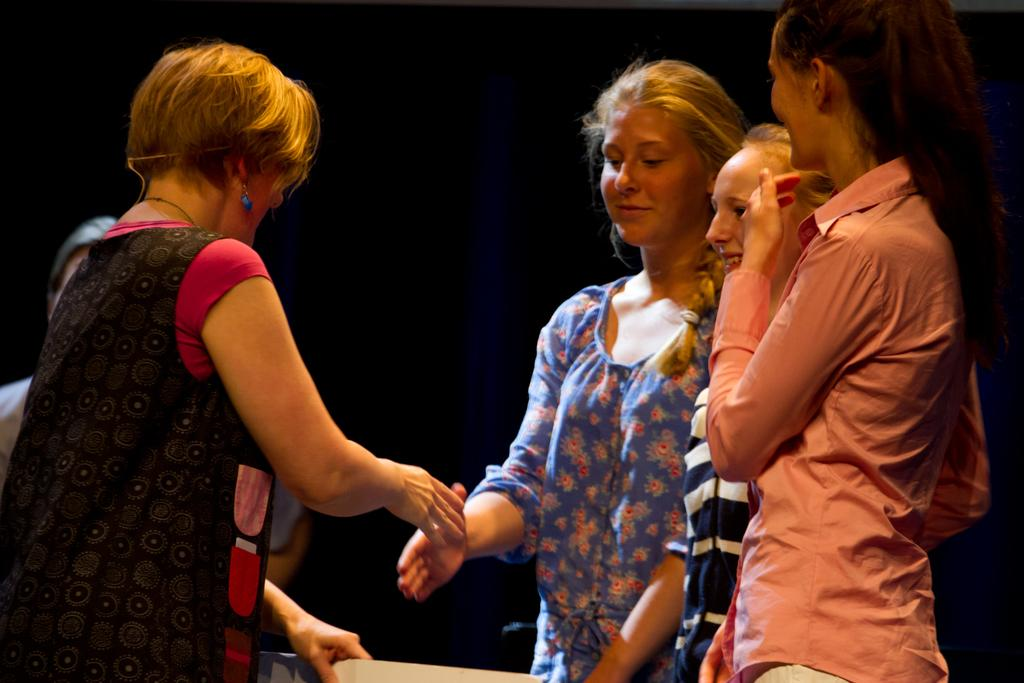What is happening in the image? There are people standing in the image. Can you describe the interaction between the people in the image? A woman is holding another woman's hand in the image. What type of snails can be seen crawling on the vegetable in the image? There are no snails or vegetables present in the image. How many cats are visible in the image? There are no cats present in the image. 